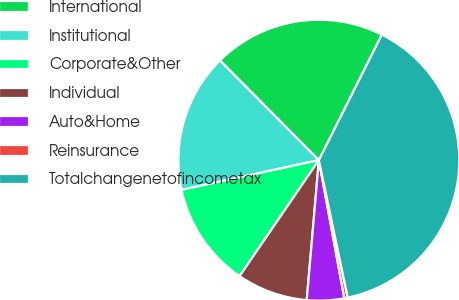<chart> <loc_0><loc_0><loc_500><loc_500><pie_chart><fcel>International<fcel>Institutional<fcel>Corporate&Other<fcel>Individual<fcel>Auto&Home<fcel>Reinsurance<fcel>Totalchangenetofincometax<nl><fcel>19.84%<fcel>15.95%<fcel>12.06%<fcel>8.17%<fcel>4.28%<fcel>0.39%<fcel>39.29%<nl></chart> 